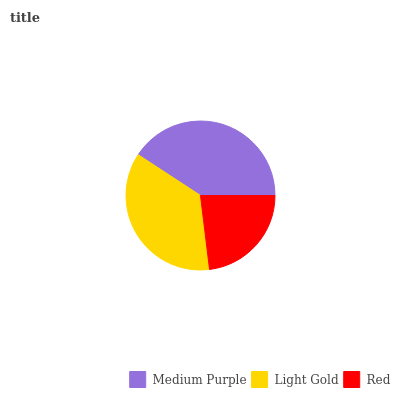Is Red the minimum?
Answer yes or no. Yes. Is Medium Purple the maximum?
Answer yes or no. Yes. Is Light Gold the minimum?
Answer yes or no. No. Is Light Gold the maximum?
Answer yes or no. No. Is Medium Purple greater than Light Gold?
Answer yes or no. Yes. Is Light Gold less than Medium Purple?
Answer yes or no. Yes. Is Light Gold greater than Medium Purple?
Answer yes or no. No. Is Medium Purple less than Light Gold?
Answer yes or no. No. Is Light Gold the high median?
Answer yes or no. Yes. Is Light Gold the low median?
Answer yes or no. Yes. Is Medium Purple the high median?
Answer yes or no. No. Is Red the low median?
Answer yes or no. No. 